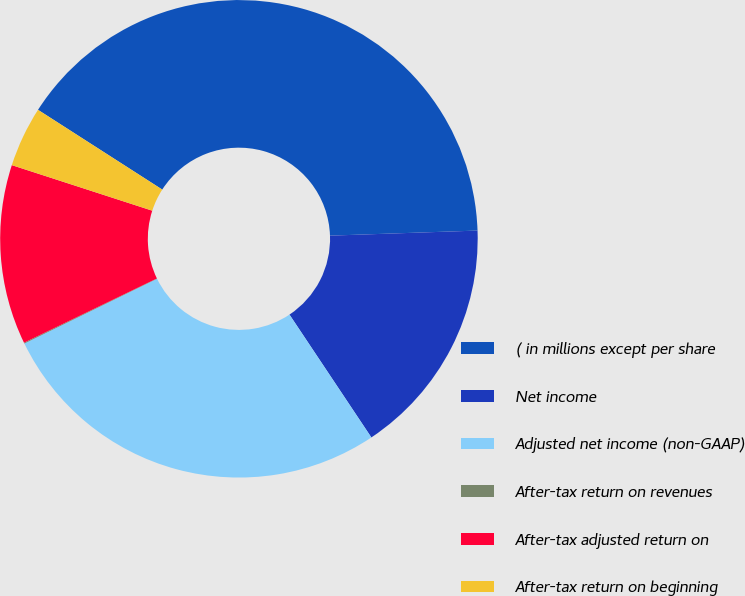<chart> <loc_0><loc_0><loc_500><loc_500><pie_chart><fcel>( in millions except per share<fcel>Net income<fcel>Adjusted net income (non-GAAP)<fcel>After-tax return on revenues<fcel>After-tax adjusted return on<fcel>After-tax return on beginning<nl><fcel>40.37%<fcel>16.19%<fcel>27.13%<fcel>0.06%<fcel>12.16%<fcel>4.09%<nl></chart> 